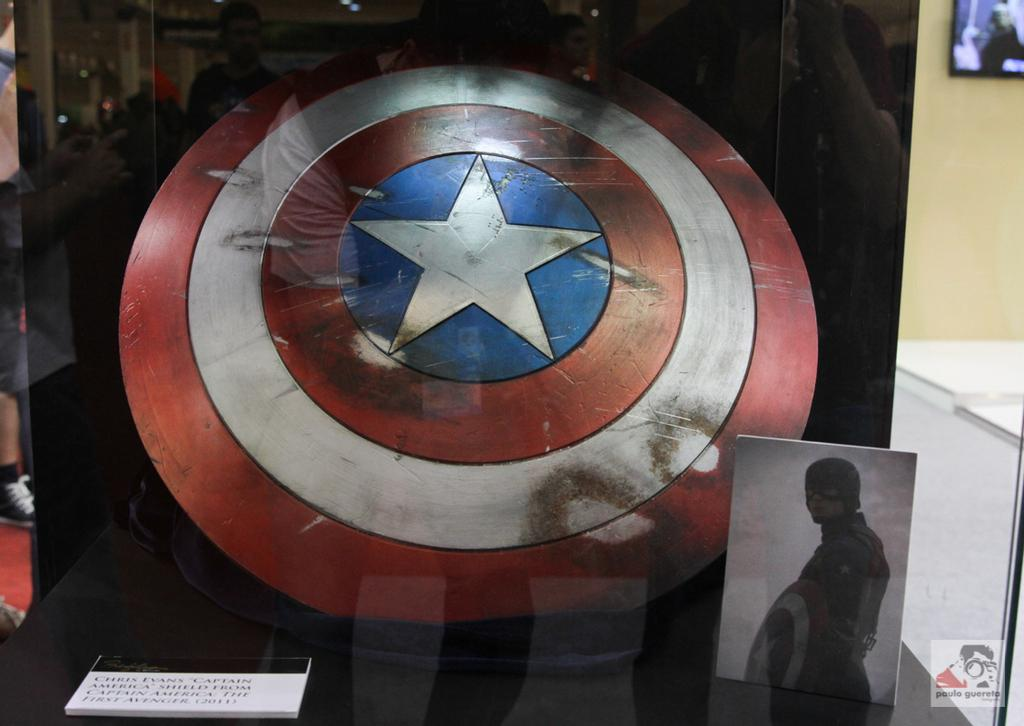What is inside the glass in the image? There is a shield inside a glass in the image. What can be seen on the shield? There are photographs on the left side of the shield. Where might this image have been taken? The image appears to have been taken in a museum. What type of heat can be felt coming from the shield in the image? There is no indication of heat in the image, and the shield is inside a glass, so it is not possible to determine if any heat is present. 